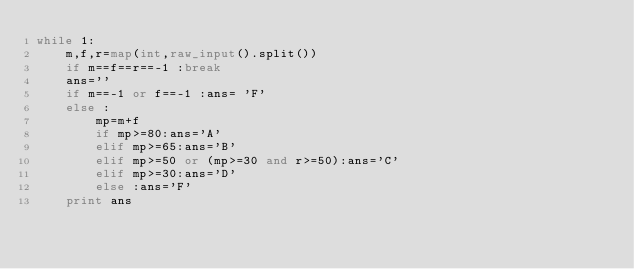Convert code to text. <code><loc_0><loc_0><loc_500><loc_500><_Python_>while 1:
    m,f,r=map(int,raw_input().split())
    if m==f==r==-1 :break
    ans=''
    if m==-1 or f==-1 :ans= 'F'
    else :
        mp=m+f
        if mp>=80:ans='A'
        elif mp>=65:ans='B'
        elif mp>=50 or (mp>=30 and r>=50):ans='C'
        elif mp>=30:ans='D'
        else :ans='F'
    print ans</code> 